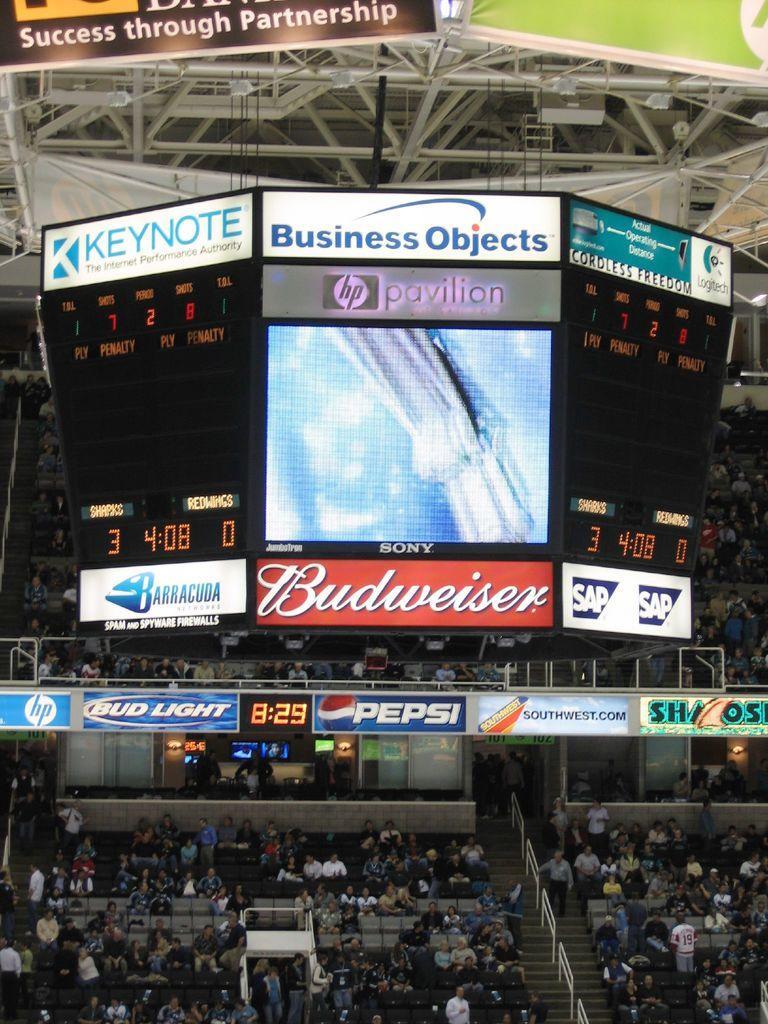Could you give a brief overview of what you see in this image? The image is taken in the stadium. In the center of the image there are screens and we can see boards. At the bottom we can see bleachers and there is crowd sitting. 